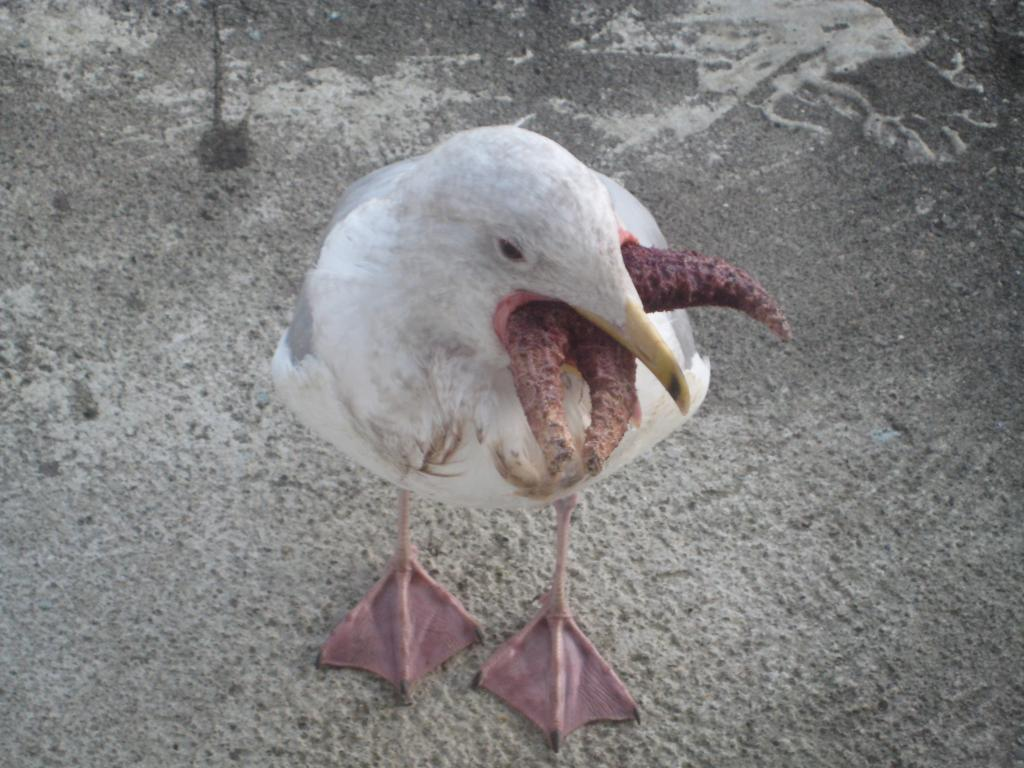What type of animal is present in the image? There is a bird in the image. What is the bird doing in the image? The bird is holding something with its beak. What type of popcorn is the bird holding in its beak? There is no popcorn present in the image; the bird is holding something else. What type of honey is the bird using to create a pin in the image? There is no honey or pin present in the image; the bird is simply holding something with its beak. 